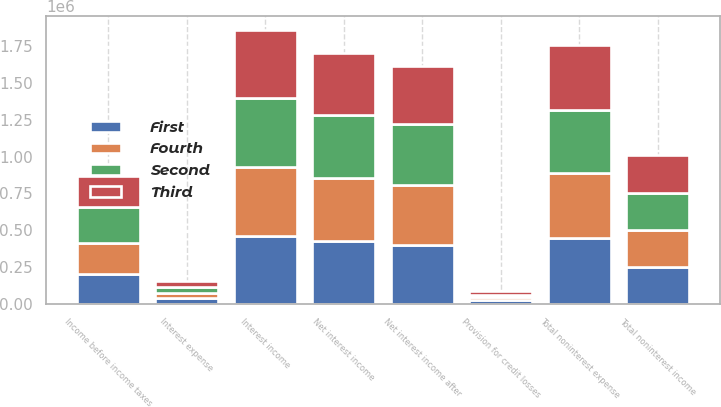<chart> <loc_0><loc_0><loc_500><loc_500><stacked_bar_chart><ecel><fcel>Interest income<fcel>Interest expense<fcel>Net interest income<fcel>Provision for credit losses<fcel>Net interest income after<fcel>Total noninterest income<fcel>Total noninterest expense<fcel>Income before income taxes<nl><fcel>Fourth<fcel>469824<fcel>39175<fcel>430649<fcel>24331<fcel>406318<fcel>249892<fcel>446009<fcel>210201<nl><fcel>Second<fcel>462912<fcel>38060<fcel>424852<fcel>11400<fcel>413452<fcel>253767<fcel>423336<fcel>243883<nl><fcel>First<fcel>462582<fcel>37645<fcel>424937<fcel>24722<fcel>400215<fcel>251919<fcel>445865<fcel>206269<nl><fcel>Third<fcel>465319<fcel>41149<fcel>424170<fcel>29592<fcel>394578<fcel>256618<fcel>442793<fcel>208403<nl></chart> 